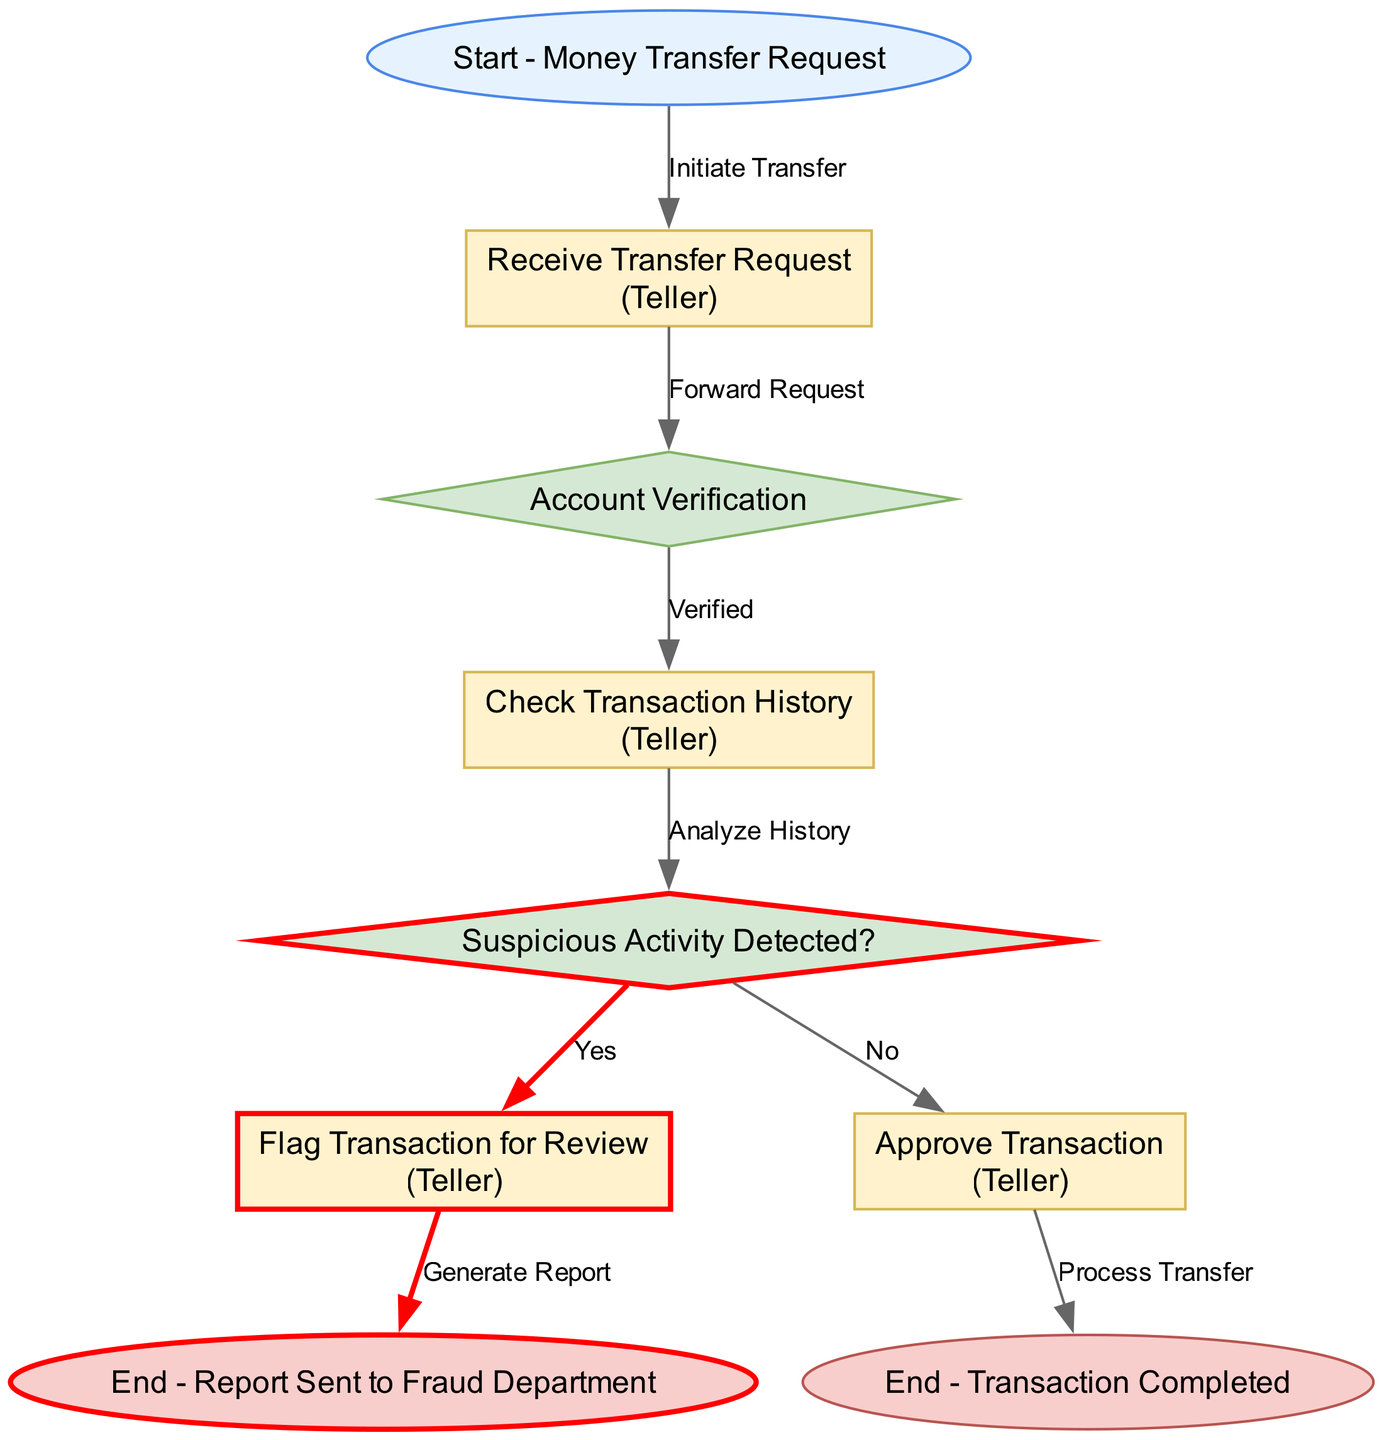What is the label of the first node in the diagram? The first node (Node1) is labeled as "Start - Money Transfer Request." This can be found by examining the list of nodes and identifying the one with the id "Node1."
Answer: Start - Money Transfer Request How many edges are there in the diagram? By counting the connections between nodes, we see there are a total of 8 edges listed in the edges section of the data.
Answer: 8 What action does the teller perform after receiving the transfer request? After the teller receives the transfer request (Node2), the next step in the flow is to "Forward Request" to the account verification node (Node3). This involves moving from one node to another based on the directed edges.
Answer: Forward Request What happens if suspicious activity is detected during account verification? If suspicious activity is detected (indicated by the decision node at Node5), the process directs to "Flag Transaction for Review" (Node6) according to the labeled edge, which connects these two nodes.
Answer: Flag Transaction for Review What is the final outcome if the transaction is approved? If the transaction is approved, the flowchart directs to the process indicating "Process Transfer" (Node8) and subsequently leads to the end node labeled "End - Transaction Completed" (Node9). This shows the completion of the transfer process.
Answer: End - Transaction Completed In which node is the suspicious activity flagged? The suspicious activity is flagged in Node6, as indicated by the label "Flag Transaction for Review," which is reached after confirming suspicious activity at Node5.
Answer: Flag Transaction for Review What does the diagram indicate should be done when no suspicious activity is detected? When no suspicious activity is detected (the “No” path from Node5), the flow indicates that the teller should "Approve Transaction" (Node8) and proceed to complete the transaction.
Answer: Approve Transaction What does the last node signify in the case of suspicious activity? The last node after marking suspicious activity is "End - Report Sent to Fraud Department" (Node7), indicating that the detected issue is referred for further investigation.
Answer: End - Report Sent to Fraud Department 